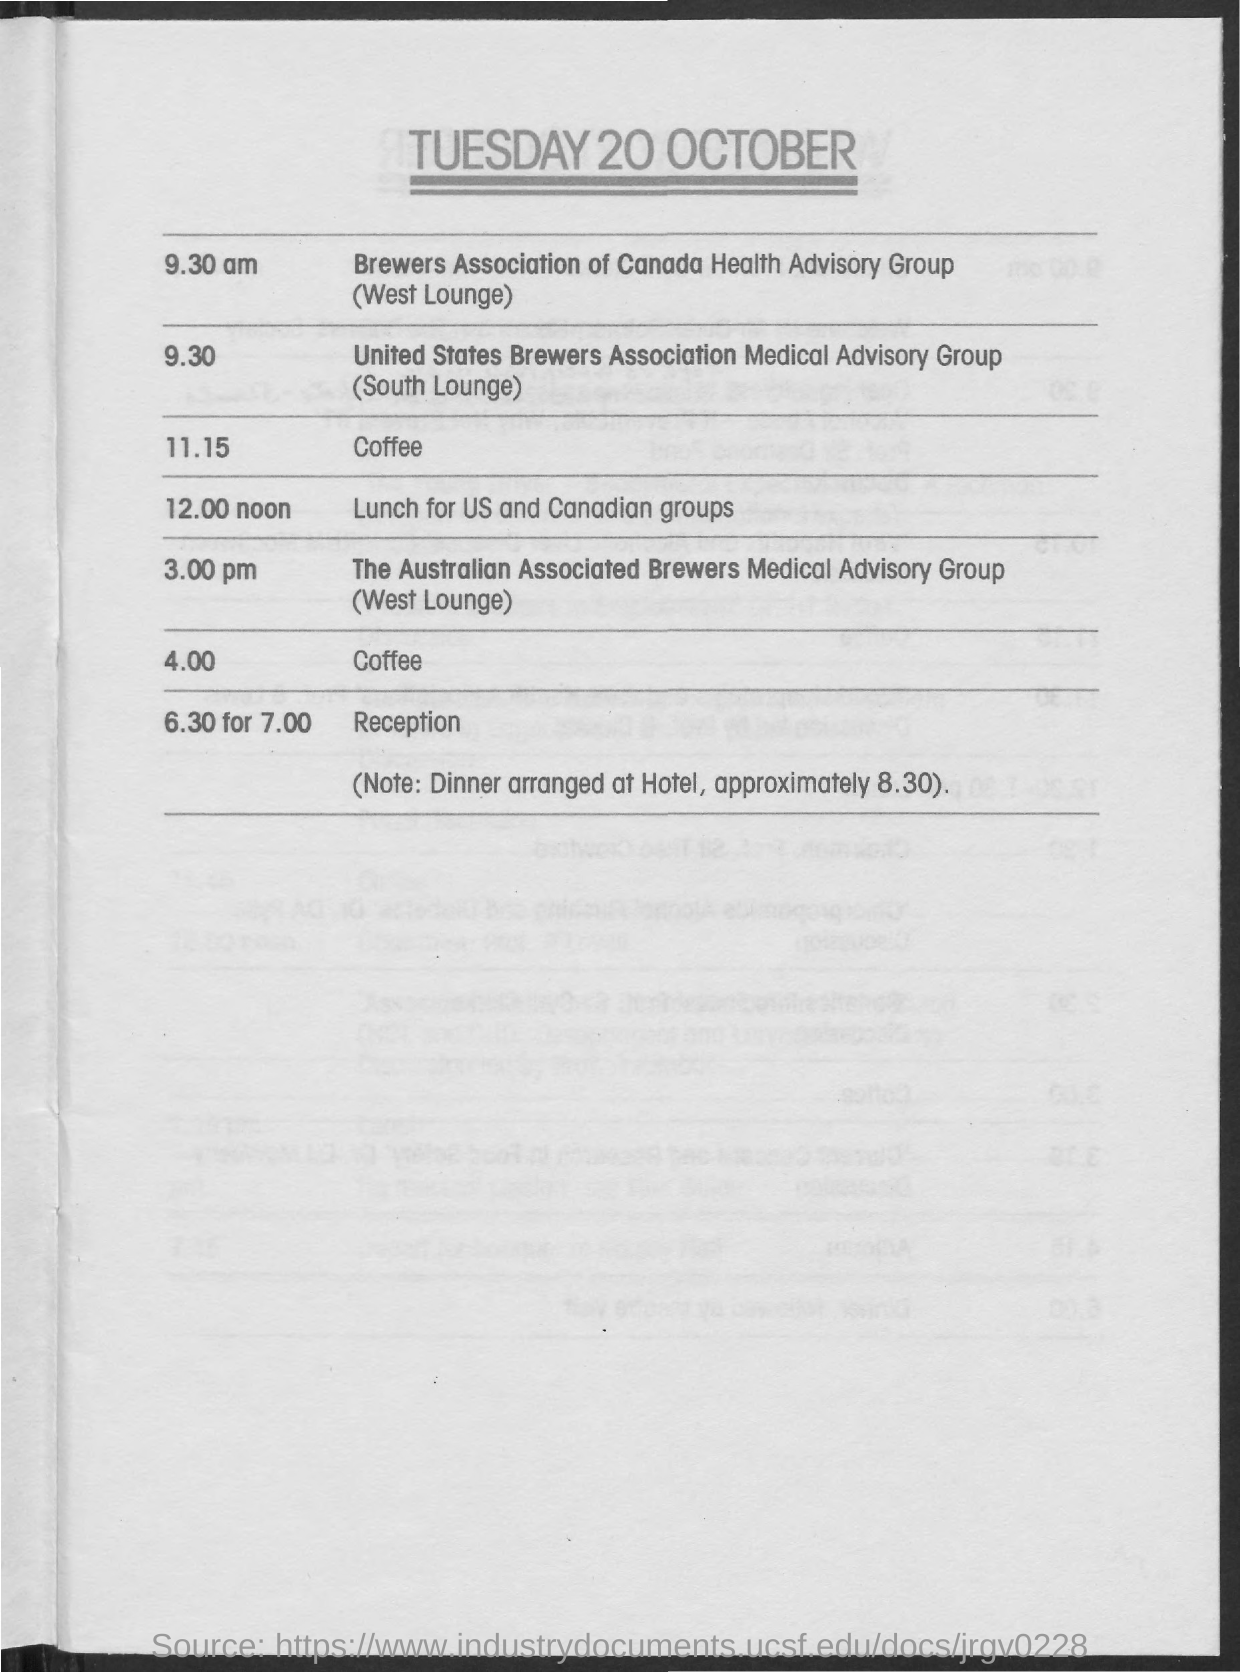What is date  at the top right corner?
Offer a very short reply. 20 OCTOBER. What is time scheduled for brewers association canada health advisory group?
Offer a very short reply. 9.30 am. What is the lounge booked for brewers association canada health advisory group?
Your answer should be compact. West Lounge. What is time scheduled for united states brewers association medical advisory group?
Provide a succinct answer. 9.30. What is the lounge booked for united states brewers association medical advisory group?
Ensure brevity in your answer.  South Lounge. What is time scheduled for lunch for us and canadian group?
Offer a terse response. 12.00 noon. What is time scheduled for reception?
Give a very brief answer. 6.30 for 7.00. What is note at bottom of schedule?
Offer a terse response. Dinner arranged at Hotel, approximately 8.30. 